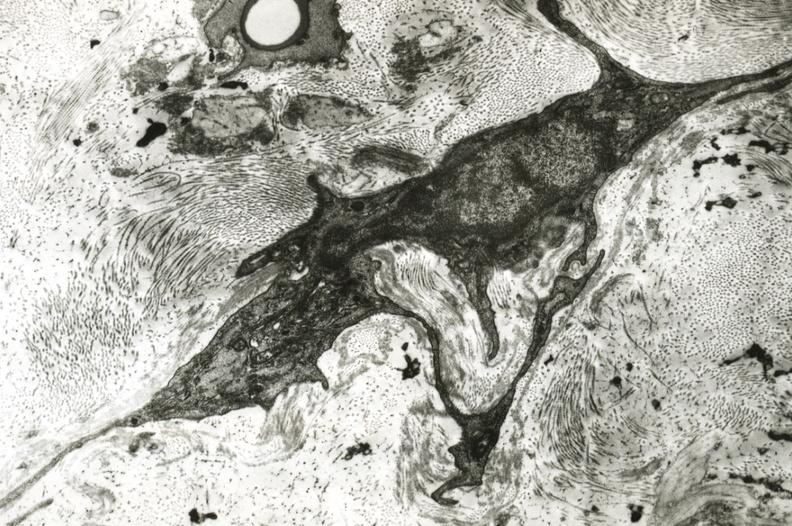s cardiovascular present?
Answer the question using a single word or phrase. Yes 